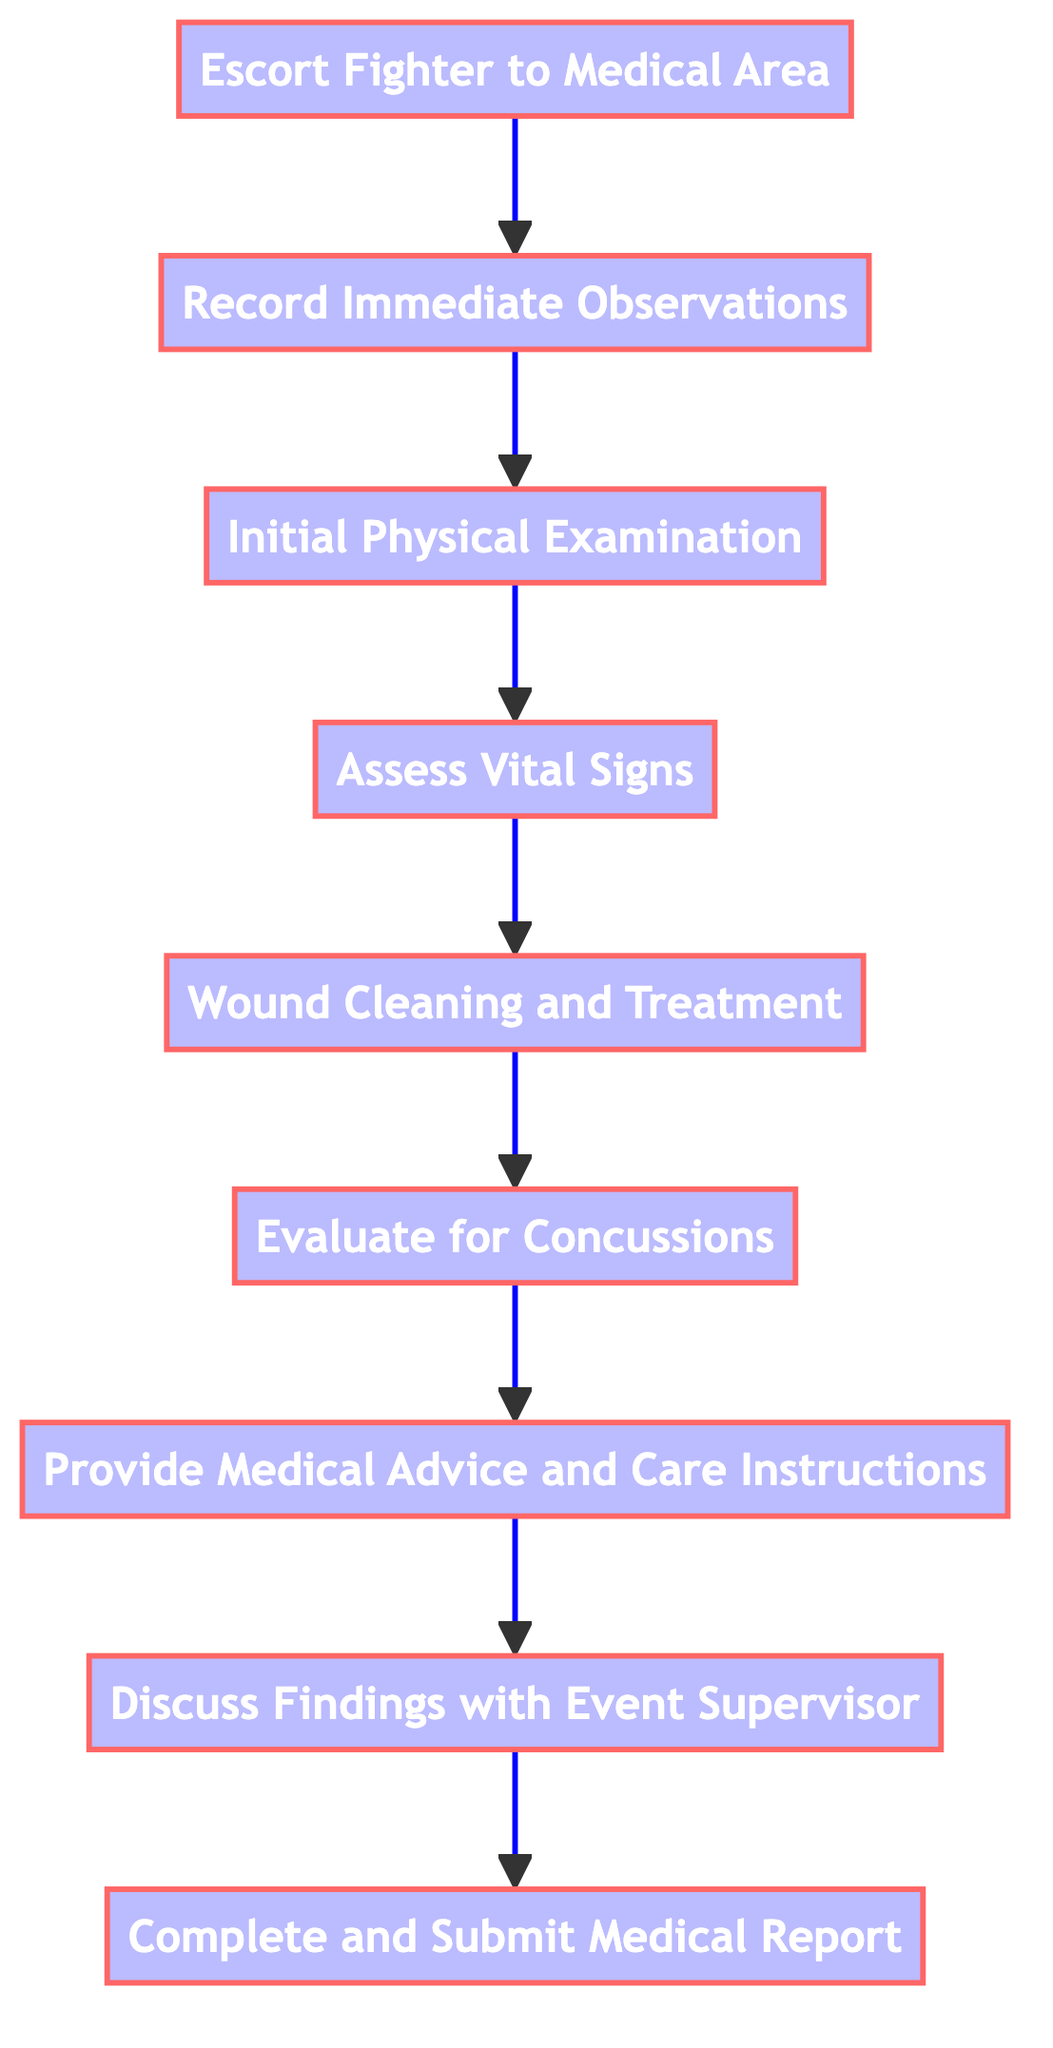What is the first step in the process? The first step is the one at the bottom of the flowchart, which is labeled "Escort Fighter to Medical Area." It is the starting point from which all other steps follow.
Answer: Escort Fighter to Medical Area How many total steps are there in the evaluation process? By counting each node in the diagram, we see there are a total of 9 distinct steps listed in the flowchart, from "Escort Fighter to Medical Area" to "Complete and Submit Medical Report."
Answer: 9 What is the last step in the process? The last step can be found at the top of the flowchart, which is labeled "Complete and Submit Medical Report." It signifies the conclusion of the evaluation process.
Answer: Complete and Submit Medical Report Which step follows "Wound Cleaning and Treatment"? The step that follows "Wound Cleaning and Treatment" is "Evaluate for Concussions." We can trace the flow of the diagram from that node to determine the next step.
Answer: Evaluate for Concussions What step involves documenting visible injuries? The step focused on documenting visible injuries is "Record Immediate Observations." It is positioned directly above "Escort Fighter to Medical Area" in the flow.
Answer: Record Immediate Observations What are the two steps preceding "Provide Medical Advice and Care Instructions"? The two steps before "Provide Medical Advice and Care Instructions" are "Evaluate for Concussions" followed by "Wound Cleaning and Treatment." We can see this sequential positioning in the flowchart.
Answer: Evaluate for Concussions, Wound Cleaning and Treatment What action is taken before assessing vital signs? Before assessing vital signs, the action taken is the "Initial Physical Examination." This step comes immediately before assessing vital signs in the flow of the process.
Answer: Initial Physical Examination What step requires collaboration with the event supervisor? The step requiring collaboration with the event supervisor is "Discuss Findings with Event Supervisor." This is a vital step for sharing and recording medical observations.
Answer: Discuss Findings with Event Supervisor What is the primary purpose of "Assess Vital Signs"? The primary purpose of "Assess Vital Signs" is to "check blood pressure, pulse rate, and respiratory rate to ensure stability." This function is crucial for monitoring the fighter's health.
Answer: check blood pressure, pulse rate, and respiratory rate to ensure stability 